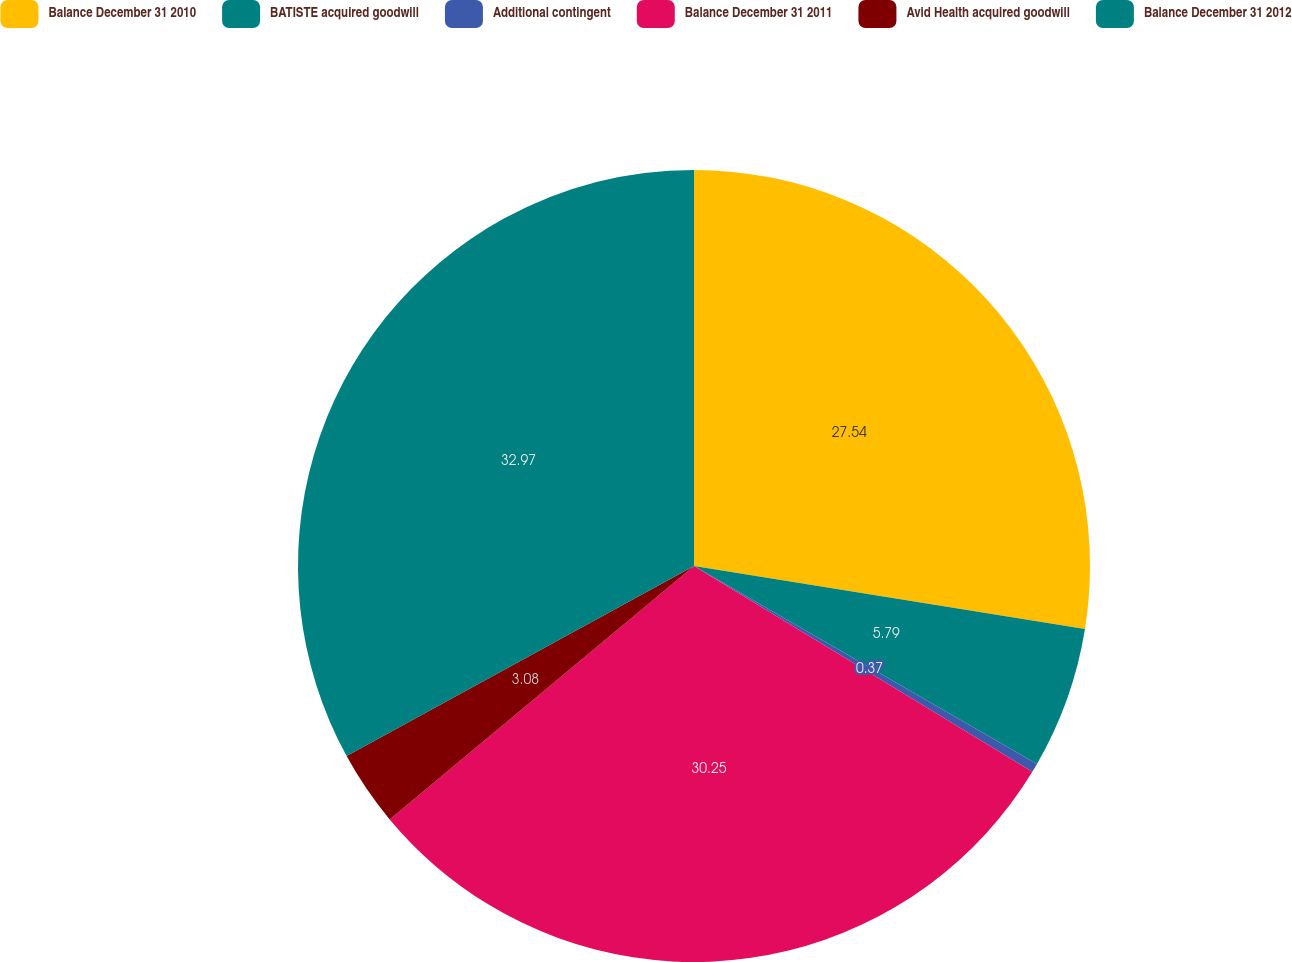Convert chart. <chart><loc_0><loc_0><loc_500><loc_500><pie_chart><fcel>Balance December 31 2010<fcel>BATISTE acquired goodwill<fcel>Additional contingent<fcel>Balance December 31 2011<fcel>Avid Health acquired goodwill<fcel>Balance December 31 2012<nl><fcel>27.54%<fcel>5.79%<fcel>0.37%<fcel>30.25%<fcel>3.08%<fcel>32.97%<nl></chart> 